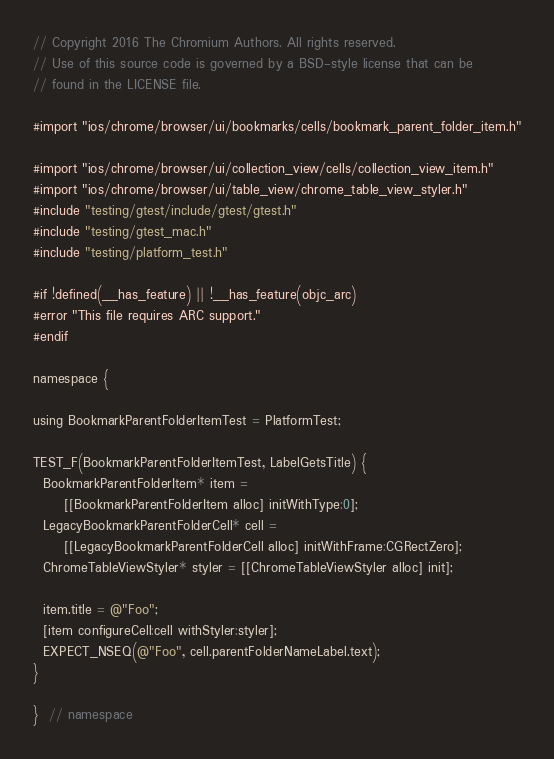Convert code to text. <code><loc_0><loc_0><loc_500><loc_500><_ObjectiveC_>// Copyright 2016 The Chromium Authors. All rights reserved.
// Use of this source code is governed by a BSD-style license that can be
// found in the LICENSE file.

#import "ios/chrome/browser/ui/bookmarks/cells/bookmark_parent_folder_item.h"

#import "ios/chrome/browser/ui/collection_view/cells/collection_view_item.h"
#import "ios/chrome/browser/ui/table_view/chrome_table_view_styler.h"
#include "testing/gtest/include/gtest/gtest.h"
#include "testing/gtest_mac.h"
#include "testing/platform_test.h"

#if !defined(__has_feature) || !__has_feature(objc_arc)
#error "This file requires ARC support."
#endif

namespace {

using BookmarkParentFolderItemTest = PlatformTest;

TEST_F(BookmarkParentFolderItemTest, LabelGetsTitle) {
  BookmarkParentFolderItem* item =
      [[BookmarkParentFolderItem alloc] initWithType:0];
  LegacyBookmarkParentFolderCell* cell =
      [[LegacyBookmarkParentFolderCell alloc] initWithFrame:CGRectZero];
  ChromeTableViewStyler* styler = [[ChromeTableViewStyler alloc] init];

  item.title = @"Foo";
  [item configureCell:cell withStyler:styler];
  EXPECT_NSEQ(@"Foo", cell.parentFolderNameLabel.text);
}

}  // namespace
</code> 